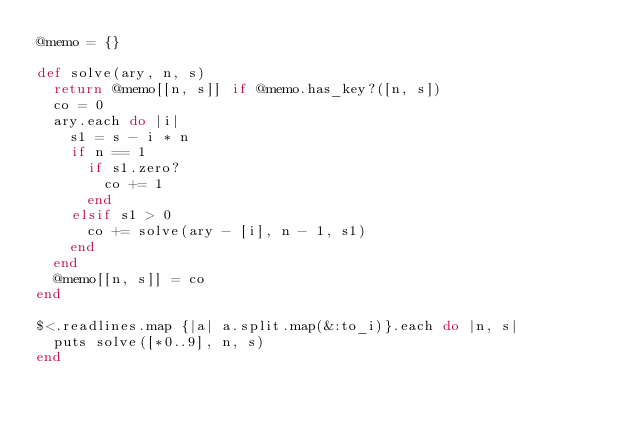<code> <loc_0><loc_0><loc_500><loc_500><_Ruby_>@memo = {}

def solve(ary, n, s)
  return @memo[[n, s]] if @memo.has_key?([n, s])
  co = 0
  ary.each do |i|
    s1 = s - i * n
    if n == 1
      if s1.zero?
        co += 1
      end
    elsif s1 > 0
      co += solve(ary - [i], n - 1, s1)
    end
  end
  @memo[[n, s]] = co
end

$<.readlines.map {|a| a.split.map(&:to_i)}.each do |n, s|
  puts solve([*0..9], n, s)
end
</code> 